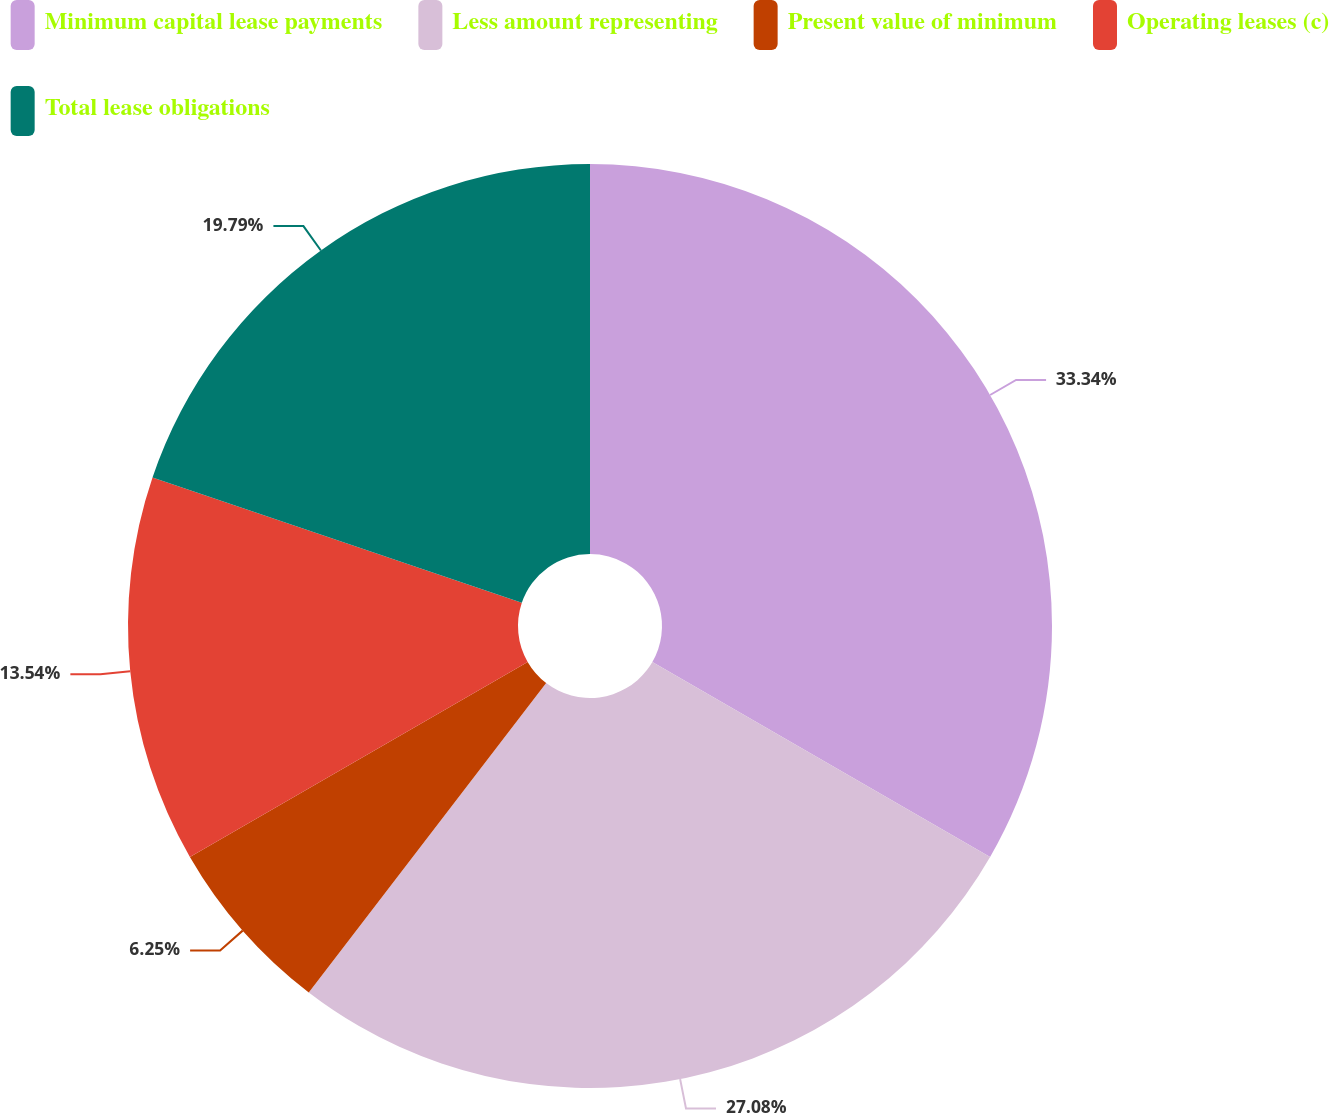<chart> <loc_0><loc_0><loc_500><loc_500><pie_chart><fcel>Minimum capital lease payments<fcel>Less amount representing<fcel>Present value of minimum<fcel>Operating leases (c)<fcel>Total lease obligations<nl><fcel>33.33%<fcel>27.08%<fcel>6.25%<fcel>13.54%<fcel>19.79%<nl></chart> 